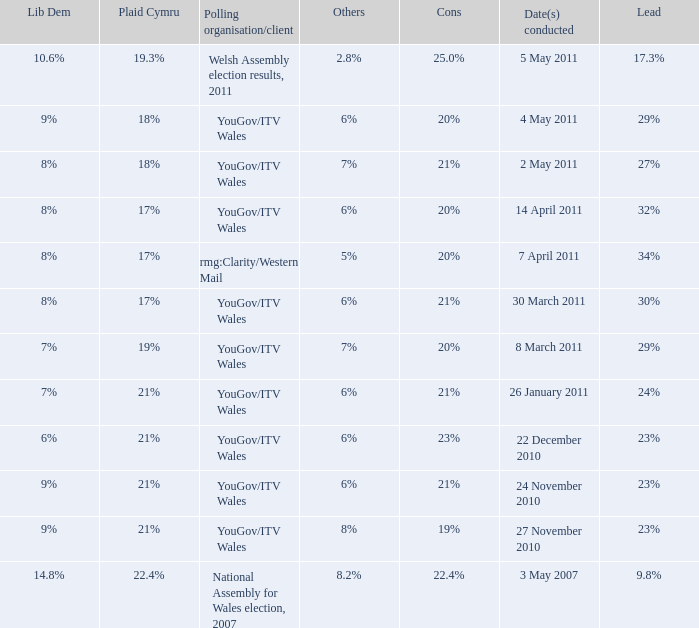What is the cons for lib dem of 8% and a lead of 27% 21%. 